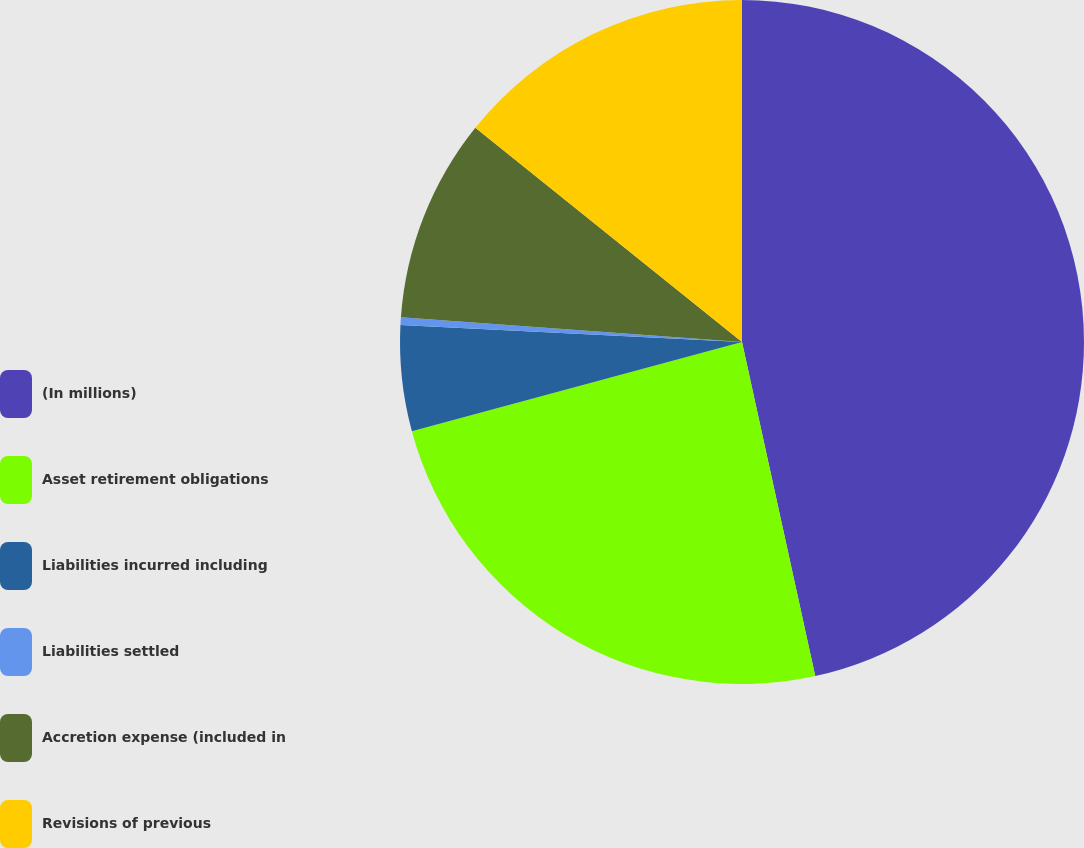Convert chart to OTSL. <chart><loc_0><loc_0><loc_500><loc_500><pie_chart><fcel>(In millions)<fcel>Asset retirement obligations<fcel>Liabilities incurred including<fcel>Liabilities settled<fcel>Accretion expense (included in<fcel>Revisions of previous<nl><fcel>46.56%<fcel>24.23%<fcel>4.99%<fcel>0.37%<fcel>9.61%<fcel>14.23%<nl></chart> 